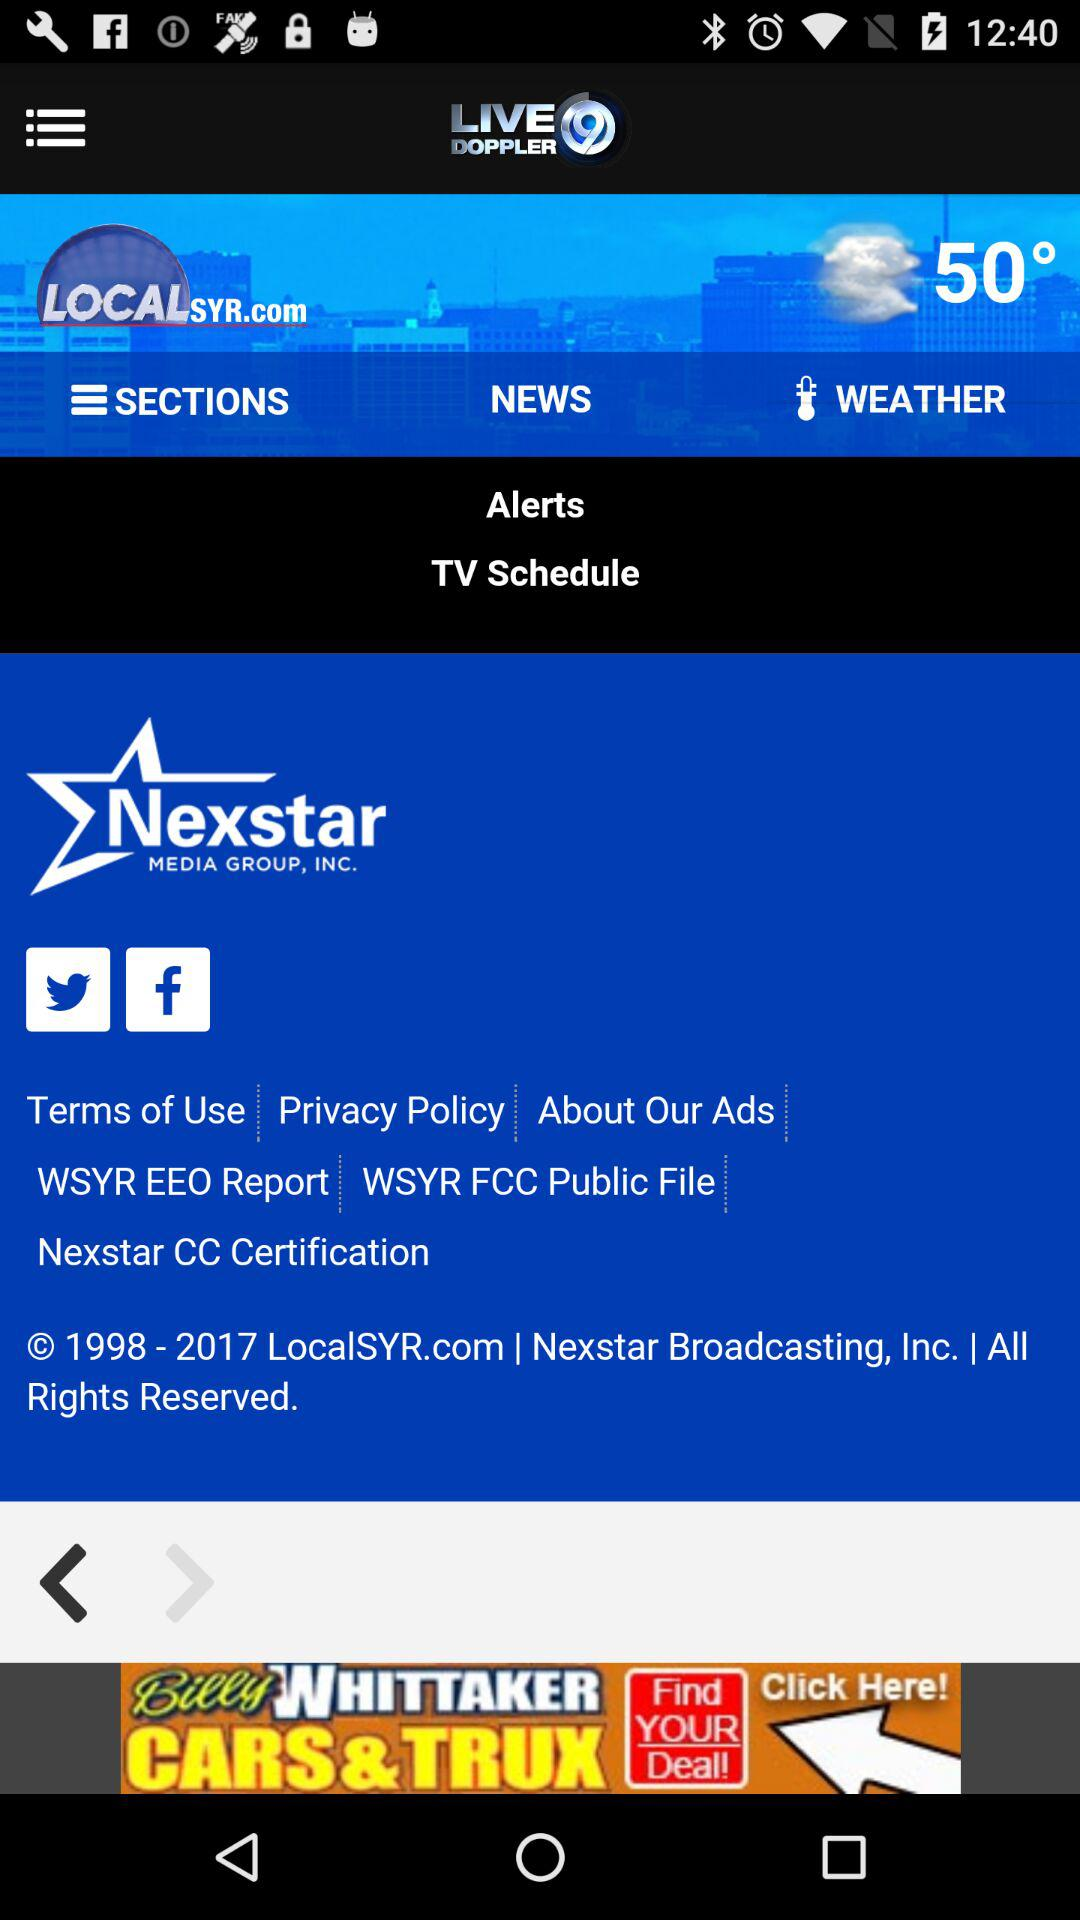What is the weather showing?
When the provided information is insufficient, respond with <no answer>. <no answer> 